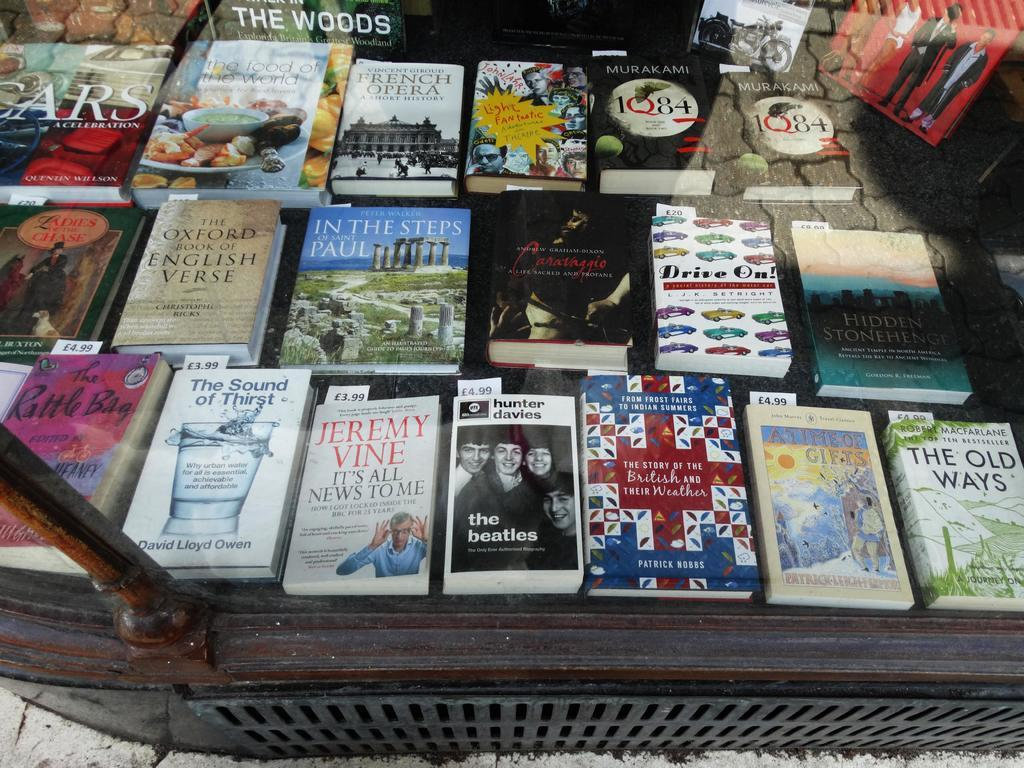<image>
Offer a succinct explanation of the picture presented. A book called The Oxford Book of English Verse sits on a table full of books. 